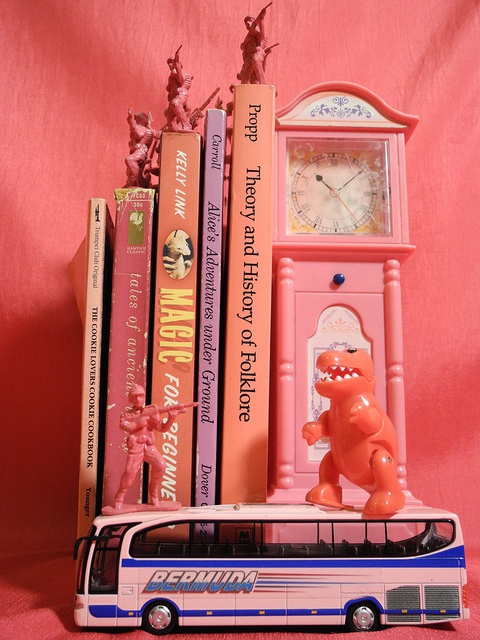Describe the objects in this image and their specific colors. I can see book in brown, salmon, and black tones, bus in brown, lightpink, black, darkblue, and salmon tones, and clock in brown, tan, and salmon tones in this image. 